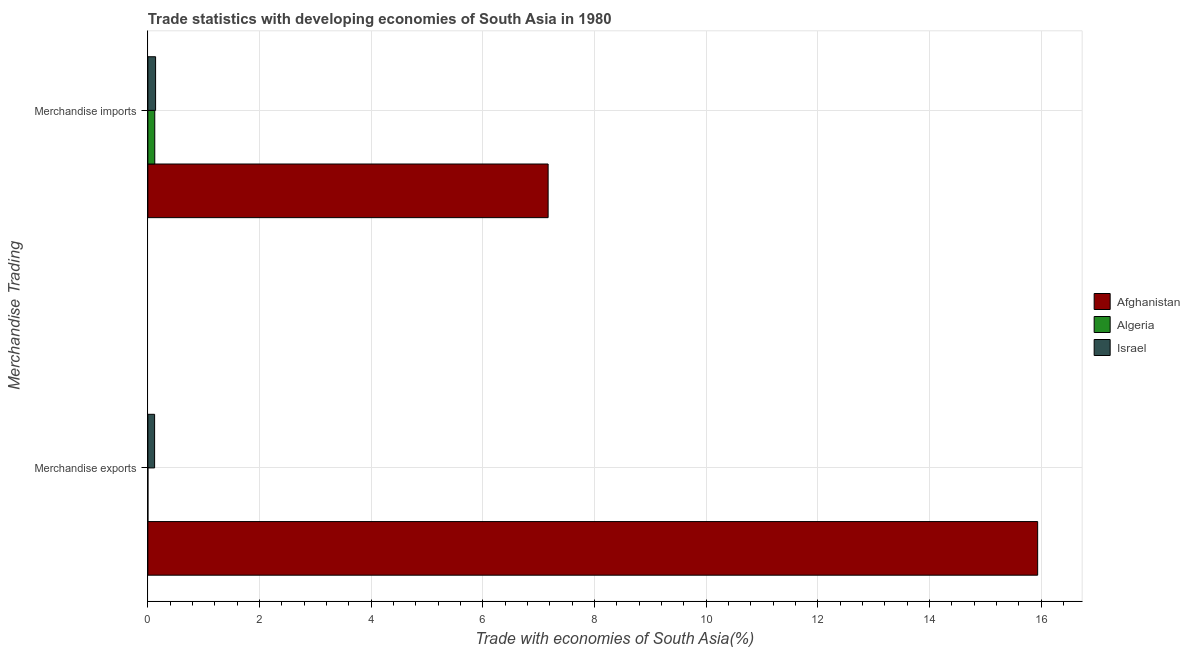How many different coloured bars are there?
Offer a very short reply. 3. How many bars are there on the 2nd tick from the top?
Keep it short and to the point. 3. How many bars are there on the 2nd tick from the bottom?
Your answer should be compact. 3. What is the label of the 1st group of bars from the top?
Make the answer very short. Merchandise imports. What is the merchandise imports in Israel?
Make the answer very short. 0.14. Across all countries, what is the maximum merchandise imports?
Your answer should be compact. 7.17. Across all countries, what is the minimum merchandise imports?
Your answer should be compact. 0.12. In which country was the merchandise imports maximum?
Offer a terse response. Afghanistan. In which country was the merchandise imports minimum?
Your answer should be very brief. Algeria. What is the total merchandise imports in the graph?
Make the answer very short. 7.43. What is the difference between the merchandise imports in Algeria and that in Afghanistan?
Keep it short and to the point. -7.05. What is the difference between the merchandise imports in Afghanistan and the merchandise exports in Israel?
Your answer should be very brief. 7.05. What is the average merchandise exports per country?
Keep it short and to the point. 5.35. What is the difference between the merchandise imports and merchandise exports in Algeria?
Your response must be concise. 0.12. In how many countries, is the merchandise exports greater than 14 %?
Give a very brief answer. 1. What is the ratio of the merchandise exports in Afghanistan to that in Algeria?
Keep it short and to the point. 2.49e+05. In how many countries, is the merchandise exports greater than the average merchandise exports taken over all countries?
Your answer should be compact. 1. What does the 3rd bar from the top in Merchandise imports represents?
Provide a succinct answer. Afghanistan. What does the 1st bar from the bottom in Merchandise imports represents?
Your response must be concise. Afghanistan. How many countries are there in the graph?
Offer a terse response. 3. What is the difference between two consecutive major ticks on the X-axis?
Make the answer very short. 2. Does the graph contain grids?
Your answer should be compact. Yes. Where does the legend appear in the graph?
Your answer should be compact. Center right. What is the title of the graph?
Your response must be concise. Trade statistics with developing economies of South Asia in 1980. What is the label or title of the X-axis?
Provide a short and direct response. Trade with economies of South Asia(%). What is the label or title of the Y-axis?
Make the answer very short. Merchandise Trading. What is the Trade with economies of South Asia(%) of Afghanistan in Merchandise exports?
Offer a terse response. 15.94. What is the Trade with economies of South Asia(%) of Algeria in Merchandise exports?
Give a very brief answer. 6.40152817280541e-5. What is the Trade with economies of South Asia(%) in Israel in Merchandise exports?
Your answer should be very brief. 0.12. What is the Trade with economies of South Asia(%) in Afghanistan in Merchandise imports?
Keep it short and to the point. 7.17. What is the Trade with economies of South Asia(%) of Algeria in Merchandise imports?
Your answer should be very brief. 0.12. What is the Trade with economies of South Asia(%) of Israel in Merchandise imports?
Keep it short and to the point. 0.14. Across all Merchandise Trading, what is the maximum Trade with economies of South Asia(%) of Afghanistan?
Give a very brief answer. 15.94. Across all Merchandise Trading, what is the maximum Trade with economies of South Asia(%) of Algeria?
Make the answer very short. 0.12. Across all Merchandise Trading, what is the maximum Trade with economies of South Asia(%) in Israel?
Your response must be concise. 0.14. Across all Merchandise Trading, what is the minimum Trade with economies of South Asia(%) of Afghanistan?
Provide a succinct answer. 7.17. Across all Merchandise Trading, what is the minimum Trade with economies of South Asia(%) in Algeria?
Provide a short and direct response. 6.40152817280541e-5. Across all Merchandise Trading, what is the minimum Trade with economies of South Asia(%) in Israel?
Keep it short and to the point. 0.12. What is the total Trade with economies of South Asia(%) of Afghanistan in the graph?
Give a very brief answer. 23.1. What is the total Trade with economies of South Asia(%) of Algeria in the graph?
Your answer should be very brief. 0.12. What is the total Trade with economies of South Asia(%) in Israel in the graph?
Give a very brief answer. 0.26. What is the difference between the Trade with economies of South Asia(%) of Afghanistan in Merchandise exports and that in Merchandise imports?
Offer a terse response. 8.77. What is the difference between the Trade with economies of South Asia(%) of Algeria in Merchandise exports and that in Merchandise imports?
Give a very brief answer. -0.12. What is the difference between the Trade with economies of South Asia(%) in Israel in Merchandise exports and that in Merchandise imports?
Your answer should be compact. -0.02. What is the difference between the Trade with economies of South Asia(%) of Afghanistan in Merchandise exports and the Trade with economies of South Asia(%) of Algeria in Merchandise imports?
Provide a succinct answer. 15.81. What is the difference between the Trade with economies of South Asia(%) of Afghanistan in Merchandise exports and the Trade with economies of South Asia(%) of Israel in Merchandise imports?
Offer a very short reply. 15.8. What is the difference between the Trade with economies of South Asia(%) in Algeria in Merchandise exports and the Trade with economies of South Asia(%) in Israel in Merchandise imports?
Make the answer very short. -0.14. What is the average Trade with economies of South Asia(%) in Afghanistan per Merchandise Trading?
Keep it short and to the point. 11.55. What is the average Trade with economies of South Asia(%) in Algeria per Merchandise Trading?
Give a very brief answer. 0.06. What is the average Trade with economies of South Asia(%) of Israel per Merchandise Trading?
Make the answer very short. 0.13. What is the difference between the Trade with economies of South Asia(%) of Afghanistan and Trade with economies of South Asia(%) of Algeria in Merchandise exports?
Make the answer very short. 15.94. What is the difference between the Trade with economies of South Asia(%) in Afghanistan and Trade with economies of South Asia(%) in Israel in Merchandise exports?
Offer a terse response. 15.82. What is the difference between the Trade with economies of South Asia(%) of Algeria and Trade with economies of South Asia(%) of Israel in Merchandise exports?
Give a very brief answer. -0.12. What is the difference between the Trade with economies of South Asia(%) in Afghanistan and Trade with economies of South Asia(%) in Algeria in Merchandise imports?
Give a very brief answer. 7.04. What is the difference between the Trade with economies of South Asia(%) in Afghanistan and Trade with economies of South Asia(%) in Israel in Merchandise imports?
Provide a short and direct response. 7.03. What is the difference between the Trade with economies of South Asia(%) in Algeria and Trade with economies of South Asia(%) in Israel in Merchandise imports?
Ensure brevity in your answer.  -0.01. What is the ratio of the Trade with economies of South Asia(%) in Afghanistan in Merchandise exports to that in Merchandise imports?
Give a very brief answer. 2.22. What is the ratio of the Trade with economies of South Asia(%) in Israel in Merchandise exports to that in Merchandise imports?
Offer a terse response. 0.87. What is the difference between the highest and the second highest Trade with economies of South Asia(%) in Afghanistan?
Your response must be concise. 8.77. What is the difference between the highest and the second highest Trade with economies of South Asia(%) in Algeria?
Offer a very short reply. 0.12. What is the difference between the highest and the second highest Trade with economies of South Asia(%) in Israel?
Offer a very short reply. 0.02. What is the difference between the highest and the lowest Trade with economies of South Asia(%) in Afghanistan?
Your answer should be very brief. 8.77. What is the difference between the highest and the lowest Trade with economies of South Asia(%) in Algeria?
Offer a terse response. 0.12. What is the difference between the highest and the lowest Trade with economies of South Asia(%) in Israel?
Ensure brevity in your answer.  0.02. 